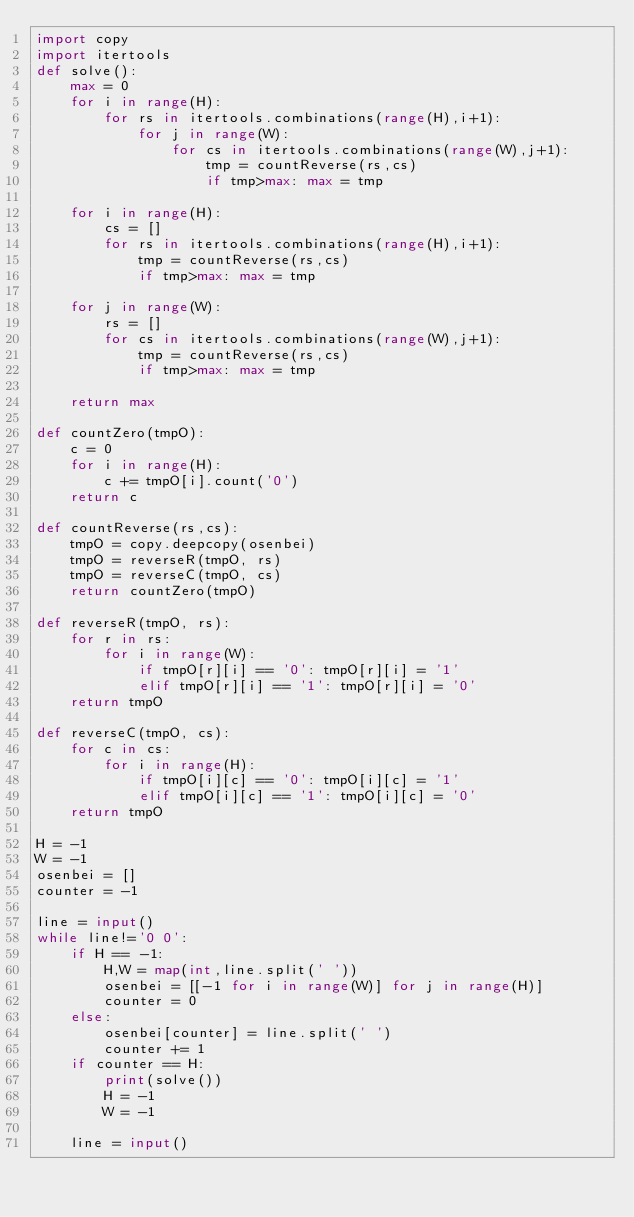Convert code to text. <code><loc_0><loc_0><loc_500><loc_500><_Python_>import copy
import itertools
def solve():
    max = 0
    for i in range(H):
        for rs in itertools.combinations(range(H),i+1):
            for j in range(W):
                for cs in itertools.combinations(range(W),j+1):
                    tmp = countReverse(rs,cs)
                    if tmp>max: max = tmp
                    
    for i in range(H):
        cs = []
        for rs in itertools.combinations(range(H),i+1):
            tmp = countReverse(rs,cs)
            if tmp>max: max = tmp

    for j in range(W):
        rs = []
        for cs in itertools.combinations(range(W),j+1):
            tmp = countReverse(rs,cs)
            if tmp>max: max = tmp
            
    return max

def countZero(tmpO):
    c = 0
    for i in range(H):
        c += tmpO[i].count('0')
    return c

def countReverse(rs,cs):
    tmpO = copy.deepcopy(osenbei)
    tmpO = reverseR(tmpO, rs)
    tmpO = reverseC(tmpO, cs)
    return countZero(tmpO)

def reverseR(tmpO, rs):
    for r in rs:
        for i in range(W):
            if tmpO[r][i] == '0': tmpO[r][i] = '1'
            elif tmpO[r][i] == '1': tmpO[r][i] = '0'
    return tmpO

def reverseC(tmpO, cs):
    for c in cs:
        for i in range(H):
            if tmpO[i][c] == '0': tmpO[i][c] = '1'
            elif tmpO[i][c] == '1': tmpO[i][c] = '0'
    return tmpO

H = -1
W = -1
osenbei = []
counter = -1

line = input()
while line!='0 0':
    if H == -1:
        H,W = map(int,line.split(' '))
        osenbei = [[-1 for i in range(W)] for j in range(H)]
        counter = 0
    else:
        osenbei[counter] = line.split(' ')
        counter += 1
    if counter == H:
        print(solve())
        H = -1
        W = -1
        
    line = input()</code> 